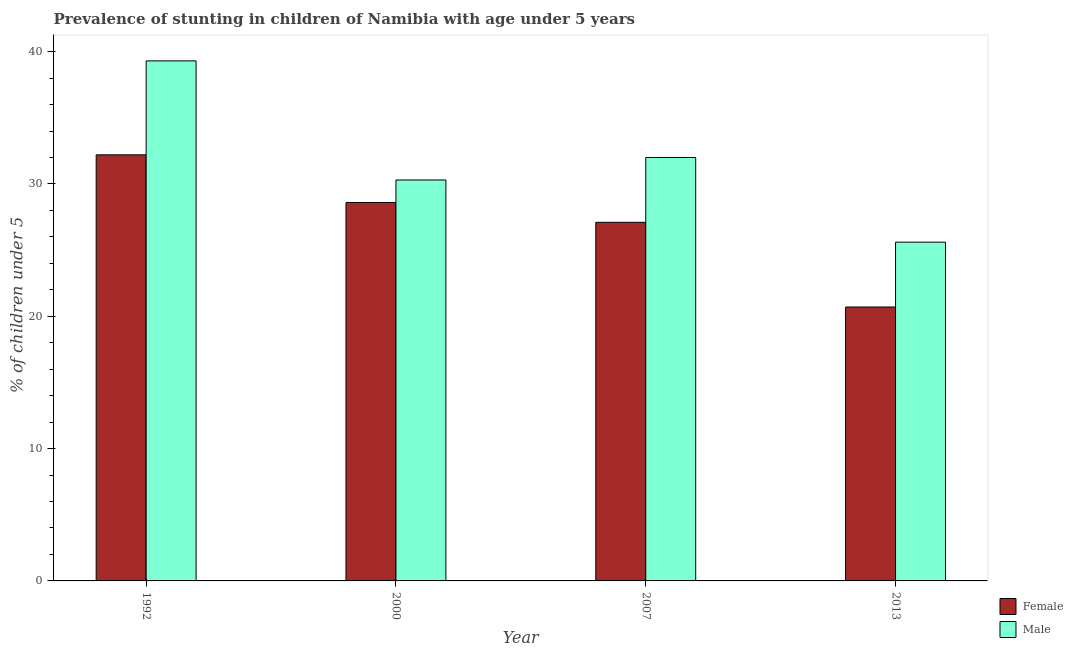How many different coloured bars are there?
Your response must be concise. 2. How many groups of bars are there?
Give a very brief answer. 4. How many bars are there on the 1st tick from the left?
Give a very brief answer. 2. What is the label of the 4th group of bars from the left?
Provide a short and direct response. 2013. In how many cases, is the number of bars for a given year not equal to the number of legend labels?
Ensure brevity in your answer.  0. What is the percentage of stunted female children in 2007?
Provide a short and direct response. 27.1. Across all years, what is the maximum percentage of stunted male children?
Provide a succinct answer. 39.3. Across all years, what is the minimum percentage of stunted male children?
Offer a terse response. 25.6. In which year was the percentage of stunted male children minimum?
Offer a very short reply. 2013. What is the total percentage of stunted male children in the graph?
Your answer should be compact. 127.2. What is the difference between the percentage of stunted male children in 1992 and that in 2007?
Make the answer very short. 7.3. What is the difference between the percentage of stunted female children in 1992 and the percentage of stunted male children in 2000?
Your answer should be very brief. 3.6. What is the average percentage of stunted male children per year?
Make the answer very short. 31.8. In the year 1992, what is the difference between the percentage of stunted female children and percentage of stunted male children?
Ensure brevity in your answer.  0. In how many years, is the percentage of stunted female children greater than 8 %?
Offer a very short reply. 4. What is the ratio of the percentage of stunted male children in 1992 to that in 2007?
Your answer should be very brief. 1.23. Is the percentage of stunted female children in 2007 less than that in 2013?
Give a very brief answer. No. What is the difference between the highest and the second highest percentage of stunted female children?
Keep it short and to the point. 3.6. What is the difference between the highest and the lowest percentage of stunted female children?
Offer a terse response. 11.5. What does the 2nd bar from the right in 1992 represents?
Offer a terse response. Female. Are the values on the major ticks of Y-axis written in scientific E-notation?
Provide a succinct answer. No. Where does the legend appear in the graph?
Offer a very short reply. Bottom right. What is the title of the graph?
Provide a succinct answer. Prevalence of stunting in children of Namibia with age under 5 years. Does "Infant" appear as one of the legend labels in the graph?
Offer a terse response. No. What is the label or title of the X-axis?
Your answer should be compact. Year. What is the label or title of the Y-axis?
Give a very brief answer.  % of children under 5. What is the  % of children under 5 of Female in 1992?
Make the answer very short. 32.2. What is the  % of children under 5 in Male in 1992?
Provide a succinct answer. 39.3. What is the  % of children under 5 in Female in 2000?
Make the answer very short. 28.6. What is the  % of children under 5 of Male in 2000?
Make the answer very short. 30.3. What is the  % of children under 5 of Female in 2007?
Provide a succinct answer. 27.1. What is the  % of children under 5 of Male in 2007?
Your response must be concise. 32. What is the  % of children under 5 in Female in 2013?
Make the answer very short. 20.7. What is the  % of children under 5 in Male in 2013?
Offer a very short reply. 25.6. Across all years, what is the maximum  % of children under 5 in Female?
Offer a terse response. 32.2. Across all years, what is the maximum  % of children under 5 in Male?
Keep it short and to the point. 39.3. Across all years, what is the minimum  % of children under 5 of Female?
Make the answer very short. 20.7. Across all years, what is the minimum  % of children under 5 in Male?
Keep it short and to the point. 25.6. What is the total  % of children under 5 of Female in the graph?
Your response must be concise. 108.6. What is the total  % of children under 5 in Male in the graph?
Your answer should be compact. 127.2. What is the difference between the  % of children under 5 in Female in 1992 and that in 2000?
Make the answer very short. 3.6. What is the difference between the  % of children under 5 of Female in 1992 and that in 2007?
Your answer should be very brief. 5.1. What is the difference between the  % of children under 5 in Male in 1992 and that in 2007?
Your answer should be compact. 7.3. What is the difference between the  % of children under 5 in Female in 1992 and that in 2013?
Your answer should be compact. 11.5. What is the difference between the  % of children under 5 of Male in 1992 and that in 2013?
Ensure brevity in your answer.  13.7. What is the difference between the  % of children under 5 in Female in 2000 and that in 2007?
Offer a terse response. 1.5. What is the difference between the  % of children under 5 of Male in 2000 and that in 2007?
Make the answer very short. -1.7. What is the difference between the  % of children under 5 in Male in 2000 and that in 2013?
Provide a short and direct response. 4.7. What is the difference between the  % of children under 5 in Male in 2007 and that in 2013?
Offer a very short reply. 6.4. What is the difference between the  % of children under 5 of Female in 1992 and the  % of children under 5 of Male in 2000?
Provide a succinct answer. 1.9. What is the difference between the  % of children under 5 in Female in 1992 and the  % of children under 5 in Male in 2007?
Offer a very short reply. 0.2. What is the difference between the  % of children under 5 in Female in 2000 and the  % of children under 5 in Male in 2013?
Provide a succinct answer. 3. What is the average  % of children under 5 of Female per year?
Your answer should be compact. 27.15. What is the average  % of children under 5 in Male per year?
Provide a short and direct response. 31.8. In the year 1992, what is the difference between the  % of children under 5 in Female and  % of children under 5 in Male?
Make the answer very short. -7.1. In the year 2000, what is the difference between the  % of children under 5 in Female and  % of children under 5 in Male?
Offer a terse response. -1.7. What is the ratio of the  % of children under 5 of Female in 1992 to that in 2000?
Keep it short and to the point. 1.13. What is the ratio of the  % of children under 5 of Male in 1992 to that in 2000?
Provide a succinct answer. 1.3. What is the ratio of the  % of children under 5 of Female in 1992 to that in 2007?
Ensure brevity in your answer.  1.19. What is the ratio of the  % of children under 5 of Male in 1992 to that in 2007?
Give a very brief answer. 1.23. What is the ratio of the  % of children under 5 of Female in 1992 to that in 2013?
Provide a short and direct response. 1.56. What is the ratio of the  % of children under 5 of Male in 1992 to that in 2013?
Give a very brief answer. 1.54. What is the ratio of the  % of children under 5 in Female in 2000 to that in 2007?
Provide a short and direct response. 1.06. What is the ratio of the  % of children under 5 in Male in 2000 to that in 2007?
Make the answer very short. 0.95. What is the ratio of the  % of children under 5 in Female in 2000 to that in 2013?
Offer a terse response. 1.38. What is the ratio of the  % of children under 5 of Male in 2000 to that in 2013?
Ensure brevity in your answer.  1.18. What is the ratio of the  % of children under 5 in Female in 2007 to that in 2013?
Make the answer very short. 1.31. What is the ratio of the  % of children under 5 of Male in 2007 to that in 2013?
Provide a succinct answer. 1.25. What is the difference between the highest and the second highest  % of children under 5 in Male?
Your answer should be very brief. 7.3. What is the difference between the highest and the lowest  % of children under 5 of Female?
Keep it short and to the point. 11.5. What is the difference between the highest and the lowest  % of children under 5 of Male?
Your answer should be very brief. 13.7. 